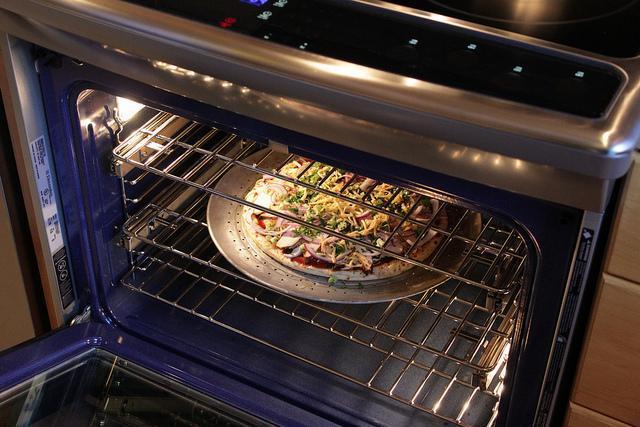Is the statement "The pizza is in the oven." accurate regarding the image?
Answer yes or no. Yes. 